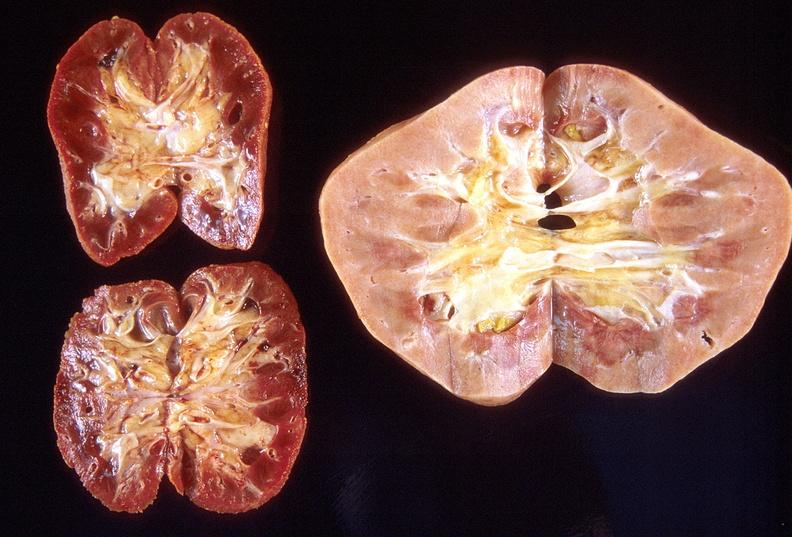does this image show left - native end stage kidneys right - renal allograft abdominal?
Answer the question using a single word or phrase. Yes 